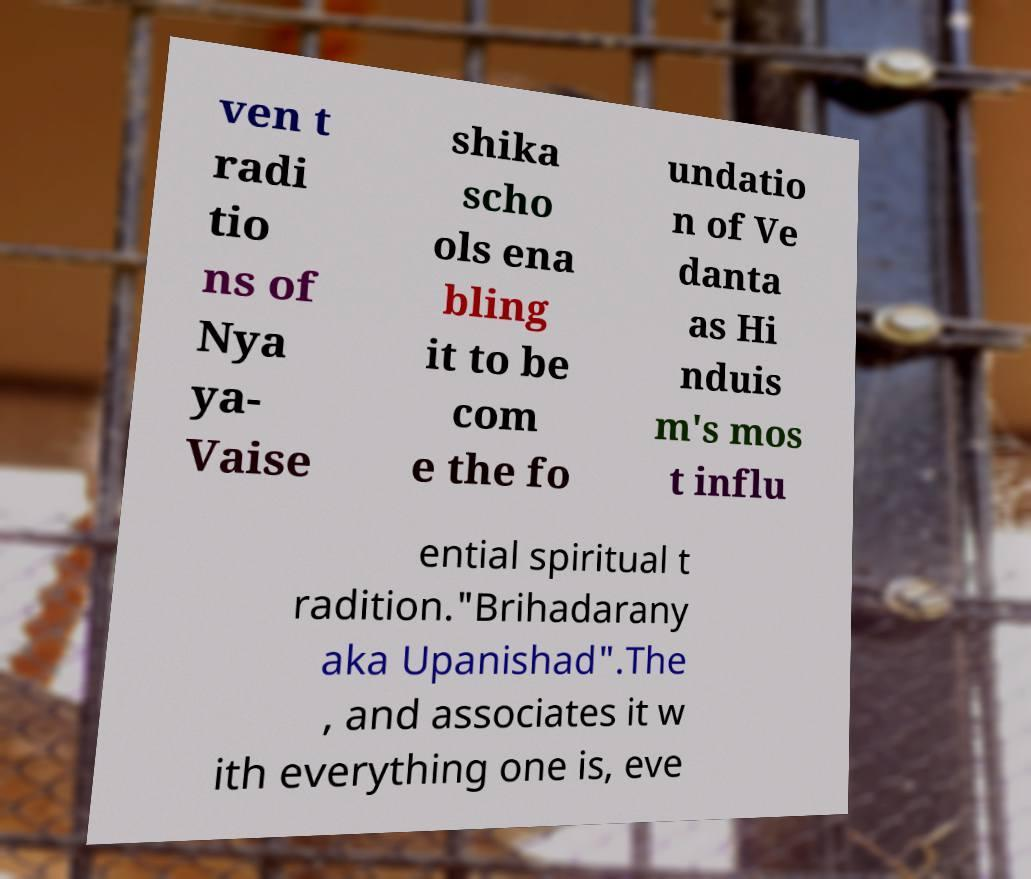What messages or text are displayed in this image? I need them in a readable, typed format. ven t radi tio ns of Nya ya- Vaise shika scho ols ena bling it to be com e the fo undatio n of Ve danta as Hi nduis m's mos t influ ential spiritual t radition."Brihadarany aka Upanishad".The , and associates it w ith everything one is, eve 